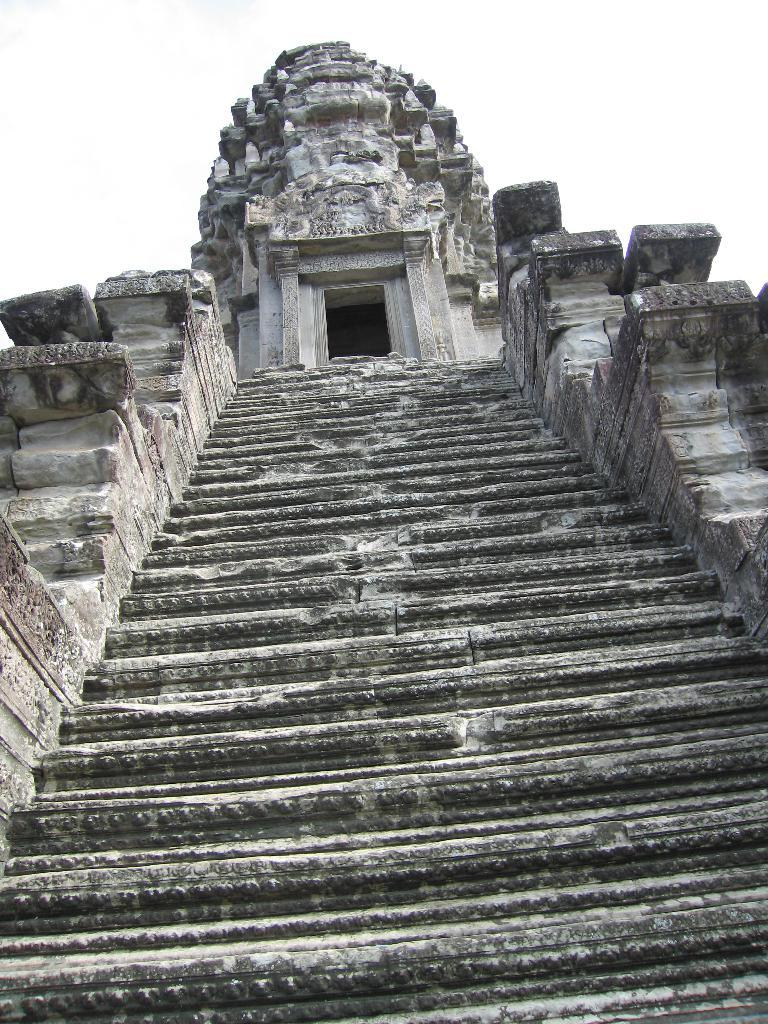What type of structure is depicted in the image? There is an ancient architecture in the image. What are some features of the ancient architecture? There are walls and steps visible in the image. What can be seen in the sky in the image? The sky is visible in the image. What type of crown is worn by the support beam in the image? There is no crown or support beam present in the image; it features ancient architecture with walls and steps. 